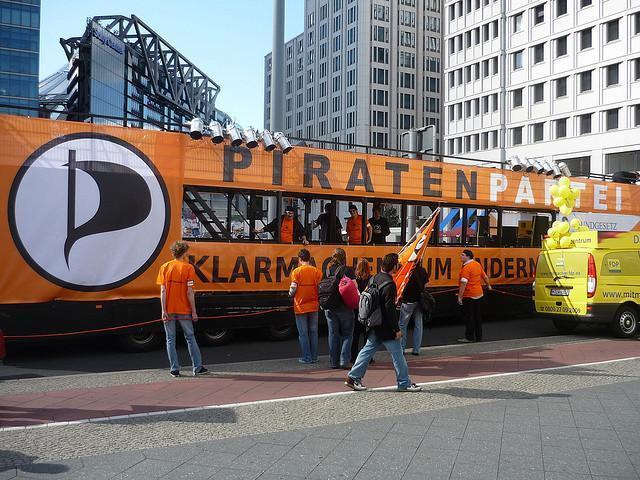How many people are on the street?
Give a very brief answer. 7. How many people are in the photo?
Give a very brief answer. 5. 